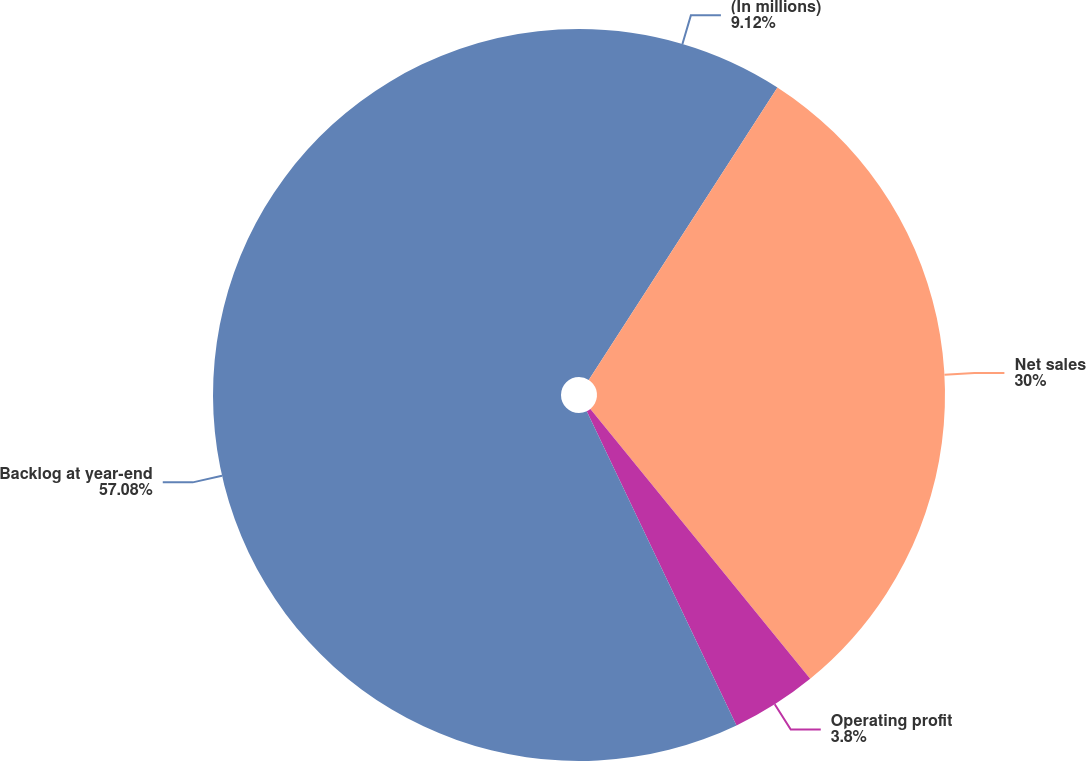Convert chart to OTSL. <chart><loc_0><loc_0><loc_500><loc_500><pie_chart><fcel>(In millions)<fcel>Net sales<fcel>Operating profit<fcel>Backlog at year-end<nl><fcel>9.12%<fcel>30.0%<fcel>3.8%<fcel>57.08%<nl></chart> 